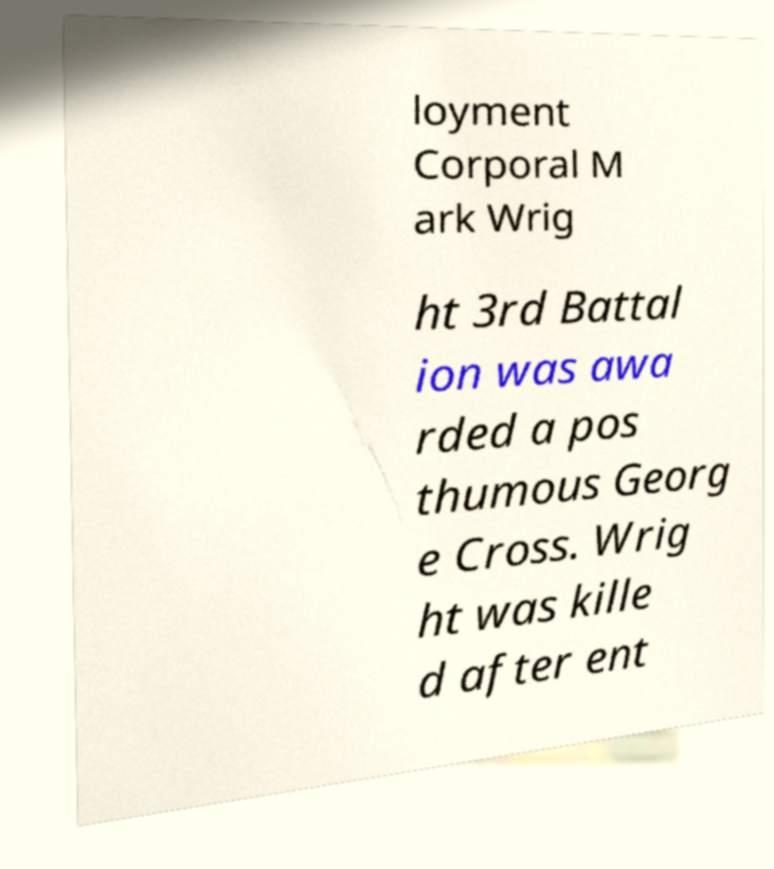Could you assist in decoding the text presented in this image and type it out clearly? loyment Corporal M ark Wrig ht 3rd Battal ion was awa rded a pos thumous Georg e Cross. Wrig ht was kille d after ent 